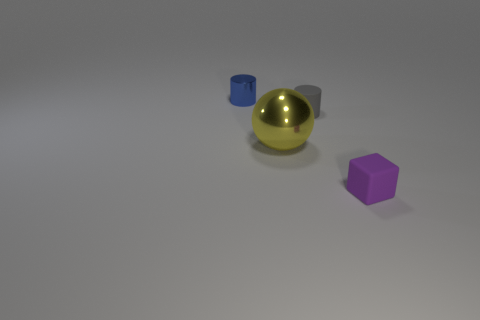What number of large things are matte cubes or matte objects?
Make the answer very short. 0. What color is the rubber object that is the same shape as the small metal thing?
Your response must be concise. Gray. Does the gray cylinder have the same size as the purple rubber cube?
Make the answer very short. Yes. What number of objects are either big metallic cylinders or shiny objects that are to the right of the blue object?
Offer a terse response. 1. The metallic object that is left of the shiny object that is right of the blue shiny object is what color?
Make the answer very short. Blue. What is the object in front of the sphere made of?
Provide a short and direct response. Rubber. The purple block has what size?
Offer a terse response. Small. Are the tiny object in front of the metal sphere and the large yellow object made of the same material?
Provide a succinct answer. No. How many tiny purple things are there?
Ensure brevity in your answer.  1. How many objects are either matte cylinders or blocks?
Keep it short and to the point. 2. 